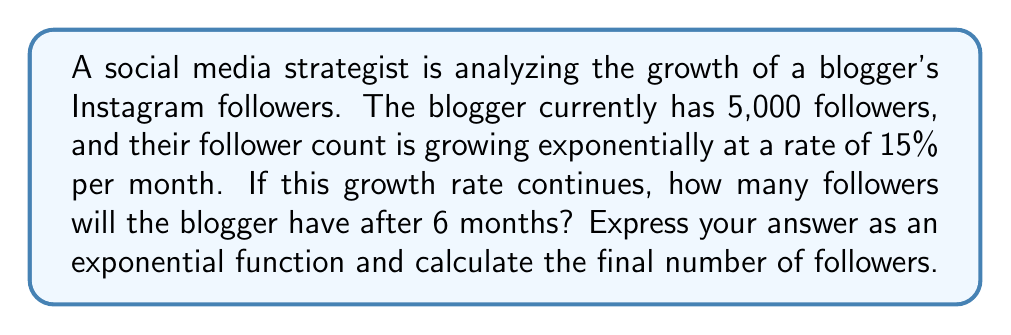Show me your answer to this math problem. Let's approach this step-by-step:

1) The general form of an exponential growth function is:

   $$A(t) = A_0 \cdot (1 + r)^t$$

   Where:
   $A(t)$ is the amount after time $t$
   $A_0$ is the initial amount
   $r$ is the growth rate (as a decimal)
   $t$ is the time period

2) In this case:
   $A_0 = 5,000$ (initial followers)
   $r = 0.15$ (15% growth rate)
   $t = 6$ (6 months)

3) Substituting these values into the formula:

   $$A(6) = 5000 \cdot (1 + 0.15)^6$$

4) Simplify inside the parentheses:

   $$A(6) = 5000 \cdot (1.15)^6$$

5) Calculate $(1.15)^6$:

   $(1.15)^6 \approx 2.3131$

6) Multiply by 5000:

   $$A(6) = 5000 \cdot 2.3131 \approx 11,565.5$$

7) Since we can't have a fractional number of followers, we round down to the nearest whole number:

   $$A(6) = 11,565\text{ followers}$$
Answer: $A(t) = 5000 \cdot (1.15)^t$; 11,565 followers 